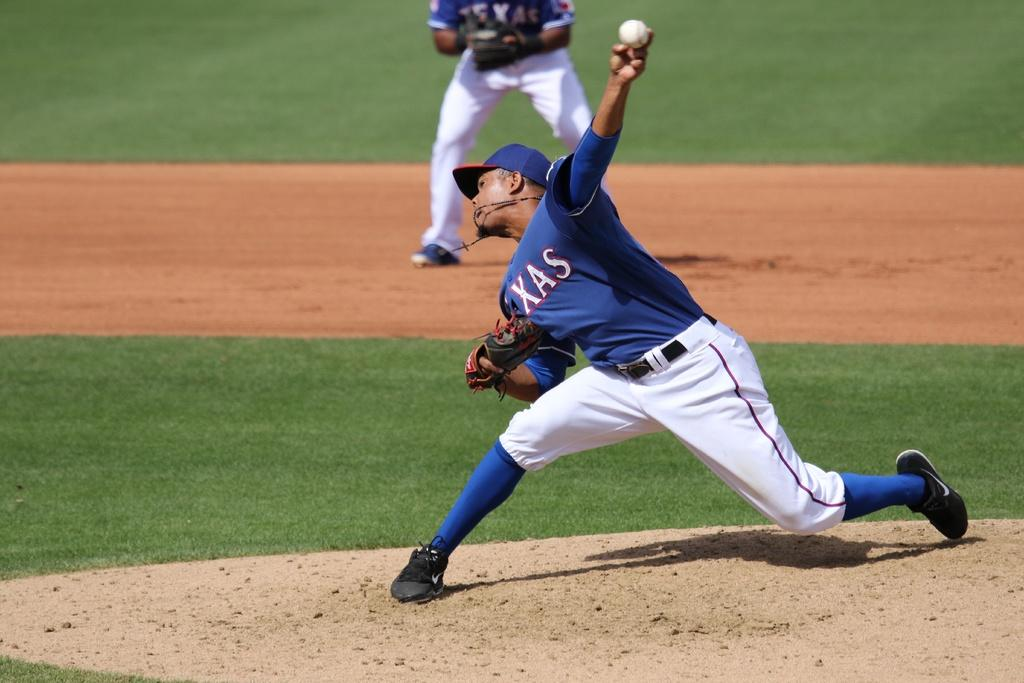Provide a one-sentence caption for the provided image. A pitcher for the Texas rangers is almost ready to release the ball. 